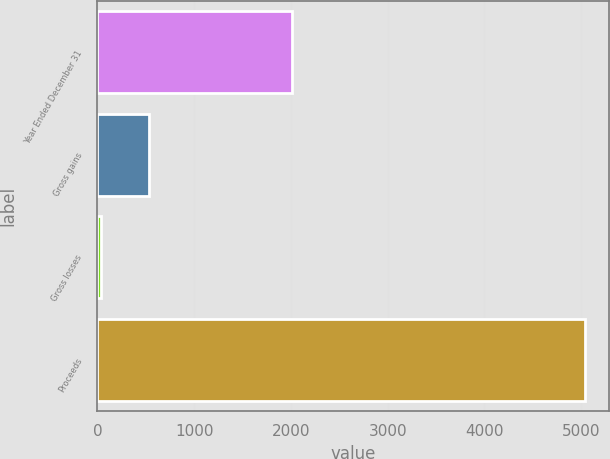<chart> <loc_0><loc_0><loc_500><loc_500><bar_chart><fcel>Year Ended December 31<fcel>Gross gains<fcel>Gross losses<fcel>Proceeds<nl><fcel>2012<fcel>535.1<fcel>35<fcel>5036<nl></chart> 